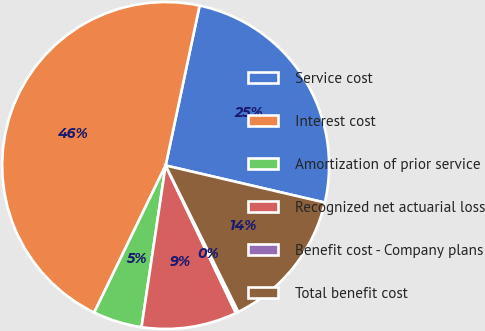Convert chart. <chart><loc_0><loc_0><loc_500><loc_500><pie_chart><fcel>Service cost<fcel>Interest cost<fcel>Amortization of prior service<fcel>Recognized net actuarial loss<fcel>Benefit cost - Company plans<fcel>Total benefit cost<nl><fcel>25.31%<fcel>46.13%<fcel>4.84%<fcel>9.43%<fcel>0.26%<fcel>14.02%<nl></chart> 